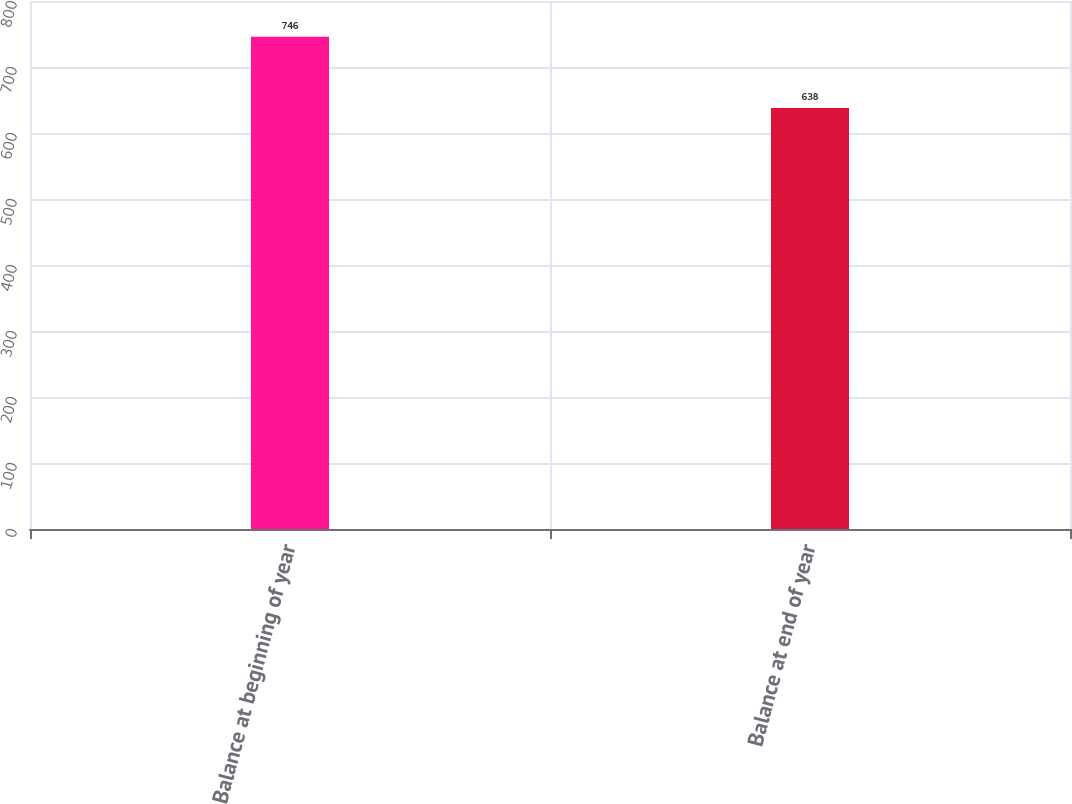Convert chart. <chart><loc_0><loc_0><loc_500><loc_500><bar_chart><fcel>Balance at beginning of year<fcel>Balance at end of year<nl><fcel>746<fcel>638<nl></chart> 